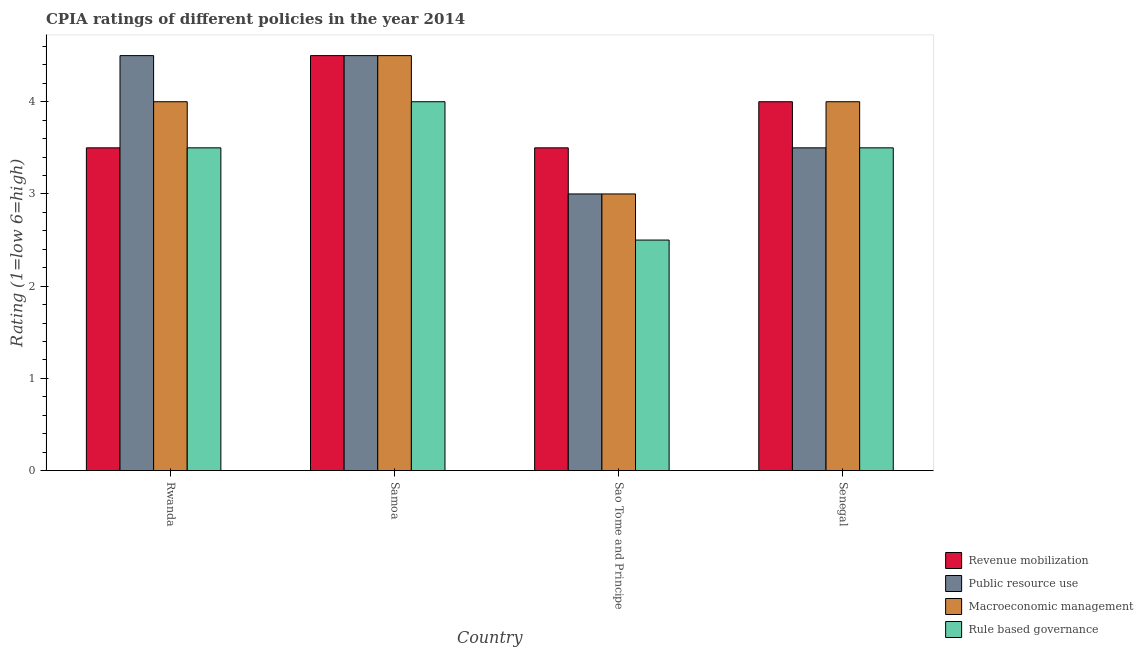How many different coloured bars are there?
Provide a succinct answer. 4. How many bars are there on the 4th tick from the right?
Offer a terse response. 4. What is the label of the 1st group of bars from the left?
Give a very brief answer. Rwanda. In how many cases, is the number of bars for a given country not equal to the number of legend labels?
Provide a succinct answer. 0. What is the cpia rating of public resource use in Rwanda?
Your response must be concise. 4.5. In which country was the cpia rating of public resource use maximum?
Your answer should be compact. Rwanda. In which country was the cpia rating of public resource use minimum?
Make the answer very short. Sao Tome and Principe. What is the difference between the cpia rating of public resource use in Rwanda and that in Sao Tome and Principe?
Provide a short and direct response. 1.5. What is the difference between the cpia rating of revenue mobilization in Samoa and the cpia rating of macroeconomic management in Sao Tome and Principe?
Your answer should be compact. 1.5. What is the average cpia rating of rule based governance per country?
Offer a very short reply. 3.38. What is the difference between the cpia rating of rule based governance and cpia rating of public resource use in Senegal?
Give a very brief answer. 0. In how many countries, is the cpia rating of public resource use greater than 0.6000000000000001 ?
Your answer should be very brief. 4. What is the ratio of the cpia rating of rule based governance in Samoa to that in Sao Tome and Principe?
Provide a succinct answer. 1.6. Is the difference between the cpia rating of public resource use in Samoa and Senegal greater than the difference between the cpia rating of revenue mobilization in Samoa and Senegal?
Offer a terse response. Yes. What is the difference between the highest and the second highest cpia rating of public resource use?
Your answer should be compact. 0. What does the 4th bar from the left in Sao Tome and Principe represents?
Ensure brevity in your answer.  Rule based governance. What does the 4th bar from the right in Samoa represents?
Provide a short and direct response. Revenue mobilization. Is it the case that in every country, the sum of the cpia rating of revenue mobilization and cpia rating of public resource use is greater than the cpia rating of macroeconomic management?
Keep it short and to the point. Yes. How many countries are there in the graph?
Keep it short and to the point. 4. What is the difference between two consecutive major ticks on the Y-axis?
Ensure brevity in your answer.  1. Does the graph contain grids?
Ensure brevity in your answer.  No. What is the title of the graph?
Keep it short and to the point. CPIA ratings of different policies in the year 2014. Does "Business regulatory environment" appear as one of the legend labels in the graph?
Provide a short and direct response. No. What is the Rating (1=low 6=high) in Public resource use in Rwanda?
Make the answer very short. 4.5. What is the Rating (1=low 6=high) in Rule based governance in Rwanda?
Offer a terse response. 3.5. What is the Rating (1=low 6=high) in Public resource use in Samoa?
Your answer should be compact. 4.5. What is the Rating (1=low 6=high) of Macroeconomic management in Samoa?
Your answer should be very brief. 4.5. What is the Rating (1=low 6=high) of Revenue mobilization in Sao Tome and Principe?
Offer a very short reply. 3.5. What is the Rating (1=low 6=high) of Rule based governance in Sao Tome and Principe?
Provide a succinct answer. 2.5. What is the Rating (1=low 6=high) in Revenue mobilization in Senegal?
Your response must be concise. 4. What is the Rating (1=low 6=high) in Public resource use in Senegal?
Your answer should be very brief. 3.5. What is the Rating (1=low 6=high) in Rule based governance in Senegal?
Your response must be concise. 3.5. Across all countries, what is the maximum Rating (1=low 6=high) of Revenue mobilization?
Offer a very short reply. 4.5. Across all countries, what is the maximum Rating (1=low 6=high) in Macroeconomic management?
Offer a very short reply. 4.5. Across all countries, what is the maximum Rating (1=low 6=high) in Rule based governance?
Provide a succinct answer. 4. Across all countries, what is the minimum Rating (1=low 6=high) in Public resource use?
Ensure brevity in your answer.  3. Across all countries, what is the minimum Rating (1=low 6=high) in Macroeconomic management?
Provide a short and direct response. 3. What is the total Rating (1=low 6=high) in Revenue mobilization in the graph?
Your answer should be compact. 15.5. What is the total Rating (1=low 6=high) in Public resource use in the graph?
Give a very brief answer. 15.5. What is the total Rating (1=low 6=high) in Rule based governance in the graph?
Your response must be concise. 13.5. What is the difference between the Rating (1=low 6=high) in Public resource use in Rwanda and that in Samoa?
Your response must be concise. 0. What is the difference between the Rating (1=low 6=high) of Macroeconomic management in Rwanda and that in Samoa?
Ensure brevity in your answer.  -0.5. What is the difference between the Rating (1=low 6=high) of Public resource use in Rwanda and that in Sao Tome and Principe?
Give a very brief answer. 1.5. What is the difference between the Rating (1=low 6=high) in Macroeconomic management in Rwanda and that in Sao Tome and Principe?
Your answer should be compact. 1. What is the difference between the Rating (1=low 6=high) of Revenue mobilization in Rwanda and that in Senegal?
Keep it short and to the point. -0.5. What is the difference between the Rating (1=low 6=high) in Public resource use in Samoa and that in Sao Tome and Principe?
Offer a very short reply. 1.5. What is the difference between the Rating (1=low 6=high) in Macroeconomic management in Samoa and that in Sao Tome and Principe?
Keep it short and to the point. 1.5. What is the difference between the Rating (1=low 6=high) of Revenue mobilization in Samoa and that in Senegal?
Your answer should be very brief. 0.5. What is the difference between the Rating (1=low 6=high) in Public resource use in Samoa and that in Senegal?
Make the answer very short. 1. What is the difference between the Rating (1=low 6=high) in Macroeconomic management in Samoa and that in Senegal?
Ensure brevity in your answer.  0.5. What is the difference between the Rating (1=low 6=high) of Rule based governance in Samoa and that in Senegal?
Keep it short and to the point. 0.5. What is the difference between the Rating (1=low 6=high) in Macroeconomic management in Sao Tome and Principe and that in Senegal?
Offer a terse response. -1. What is the difference between the Rating (1=low 6=high) of Rule based governance in Sao Tome and Principe and that in Senegal?
Ensure brevity in your answer.  -1. What is the difference between the Rating (1=low 6=high) of Revenue mobilization in Rwanda and the Rating (1=low 6=high) of Rule based governance in Samoa?
Your answer should be compact. -0.5. What is the difference between the Rating (1=low 6=high) of Public resource use in Rwanda and the Rating (1=low 6=high) of Rule based governance in Samoa?
Offer a terse response. 0.5. What is the difference between the Rating (1=low 6=high) of Revenue mobilization in Rwanda and the Rating (1=low 6=high) of Macroeconomic management in Sao Tome and Principe?
Provide a short and direct response. 0.5. What is the difference between the Rating (1=low 6=high) of Revenue mobilization in Rwanda and the Rating (1=low 6=high) of Rule based governance in Sao Tome and Principe?
Your answer should be compact. 1. What is the difference between the Rating (1=low 6=high) in Public resource use in Rwanda and the Rating (1=low 6=high) in Rule based governance in Sao Tome and Principe?
Provide a short and direct response. 2. What is the difference between the Rating (1=low 6=high) in Revenue mobilization in Rwanda and the Rating (1=low 6=high) in Public resource use in Senegal?
Keep it short and to the point. 0. What is the difference between the Rating (1=low 6=high) of Revenue mobilization in Rwanda and the Rating (1=low 6=high) of Macroeconomic management in Senegal?
Make the answer very short. -0.5. What is the difference between the Rating (1=low 6=high) of Revenue mobilization in Rwanda and the Rating (1=low 6=high) of Rule based governance in Senegal?
Offer a terse response. 0. What is the difference between the Rating (1=low 6=high) of Public resource use in Rwanda and the Rating (1=low 6=high) of Macroeconomic management in Senegal?
Your answer should be compact. 0.5. What is the difference between the Rating (1=low 6=high) in Macroeconomic management in Rwanda and the Rating (1=low 6=high) in Rule based governance in Senegal?
Your answer should be very brief. 0.5. What is the difference between the Rating (1=low 6=high) in Revenue mobilization in Samoa and the Rating (1=low 6=high) in Public resource use in Sao Tome and Principe?
Provide a succinct answer. 1.5. What is the difference between the Rating (1=low 6=high) of Public resource use in Samoa and the Rating (1=low 6=high) of Macroeconomic management in Sao Tome and Principe?
Offer a terse response. 1.5. What is the difference between the Rating (1=low 6=high) in Revenue mobilization in Samoa and the Rating (1=low 6=high) in Public resource use in Senegal?
Ensure brevity in your answer.  1. What is the difference between the Rating (1=low 6=high) of Public resource use in Samoa and the Rating (1=low 6=high) of Macroeconomic management in Senegal?
Your answer should be compact. 0.5. What is the difference between the Rating (1=low 6=high) in Public resource use in Samoa and the Rating (1=low 6=high) in Rule based governance in Senegal?
Ensure brevity in your answer.  1. What is the difference between the Rating (1=low 6=high) in Revenue mobilization in Sao Tome and Principe and the Rating (1=low 6=high) in Macroeconomic management in Senegal?
Your answer should be compact. -0.5. What is the difference between the Rating (1=low 6=high) in Revenue mobilization in Sao Tome and Principe and the Rating (1=low 6=high) in Rule based governance in Senegal?
Keep it short and to the point. 0. What is the difference between the Rating (1=low 6=high) of Public resource use in Sao Tome and Principe and the Rating (1=low 6=high) of Macroeconomic management in Senegal?
Make the answer very short. -1. What is the average Rating (1=low 6=high) in Revenue mobilization per country?
Give a very brief answer. 3.88. What is the average Rating (1=low 6=high) in Public resource use per country?
Offer a terse response. 3.88. What is the average Rating (1=low 6=high) in Macroeconomic management per country?
Offer a very short reply. 3.88. What is the average Rating (1=low 6=high) in Rule based governance per country?
Ensure brevity in your answer.  3.38. What is the difference between the Rating (1=low 6=high) in Revenue mobilization and Rating (1=low 6=high) in Macroeconomic management in Rwanda?
Provide a succinct answer. -0.5. What is the difference between the Rating (1=low 6=high) in Revenue mobilization and Rating (1=low 6=high) in Rule based governance in Rwanda?
Give a very brief answer. 0. What is the difference between the Rating (1=low 6=high) in Public resource use and Rating (1=low 6=high) in Macroeconomic management in Rwanda?
Keep it short and to the point. 0.5. What is the difference between the Rating (1=low 6=high) of Public resource use and Rating (1=low 6=high) of Rule based governance in Rwanda?
Your answer should be compact. 1. What is the difference between the Rating (1=low 6=high) of Macroeconomic management and Rating (1=low 6=high) of Rule based governance in Rwanda?
Ensure brevity in your answer.  0.5. What is the difference between the Rating (1=low 6=high) in Revenue mobilization and Rating (1=low 6=high) in Public resource use in Samoa?
Make the answer very short. 0. What is the difference between the Rating (1=low 6=high) in Revenue mobilization and Rating (1=low 6=high) in Public resource use in Sao Tome and Principe?
Ensure brevity in your answer.  0.5. What is the difference between the Rating (1=low 6=high) in Public resource use and Rating (1=low 6=high) in Macroeconomic management in Sao Tome and Principe?
Ensure brevity in your answer.  0. What is the difference between the Rating (1=low 6=high) of Public resource use and Rating (1=low 6=high) of Rule based governance in Sao Tome and Principe?
Give a very brief answer. 0.5. What is the difference between the Rating (1=low 6=high) of Revenue mobilization and Rating (1=low 6=high) of Public resource use in Senegal?
Provide a succinct answer. 0.5. What is the difference between the Rating (1=low 6=high) in Macroeconomic management and Rating (1=low 6=high) in Rule based governance in Senegal?
Provide a succinct answer. 0.5. What is the ratio of the Rating (1=low 6=high) in Revenue mobilization in Rwanda to that in Samoa?
Your answer should be very brief. 0.78. What is the ratio of the Rating (1=low 6=high) in Rule based governance in Rwanda to that in Samoa?
Offer a terse response. 0.88. What is the ratio of the Rating (1=low 6=high) of Macroeconomic management in Rwanda to that in Sao Tome and Principe?
Make the answer very short. 1.33. What is the ratio of the Rating (1=low 6=high) in Rule based governance in Rwanda to that in Sao Tome and Principe?
Provide a succinct answer. 1.4. What is the ratio of the Rating (1=low 6=high) in Revenue mobilization in Rwanda to that in Senegal?
Ensure brevity in your answer.  0.88. What is the ratio of the Rating (1=low 6=high) in Rule based governance in Samoa to that in Sao Tome and Principe?
Your answer should be very brief. 1.6. What is the ratio of the Rating (1=low 6=high) in Macroeconomic management in Samoa to that in Senegal?
Give a very brief answer. 1.12. What is the ratio of the Rating (1=low 6=high) of Rule based governance in Samoa to that in Senegal?
Provide a short and direct response. 1.14. What is the ratio of the Rating (1=low 6=high) in Rule based governance in Sao Tome and Principe to that in Senegal?
Ensure brevity in your answer.  0.71. What is the difference between the highest and the second highest Rating (1=low 6=high) in Revenue mobilization?
Keep it short and to the point. 0.5. What is the difference between the highest and the second highest Rating (1=low 6=high) of Macroeconomic management?
Your answer should be very brief. 0.5. What is the difference between the highest and the second highest Rating (1=low 6=high) of Rule based governance?
Provide a succinct answer. 0.5. What is the difference between the highest and the lowest Rating (1=low 6=high) in Revenue mobilization?
Offer a very short reply. 1. What is the difference between the highest and the lowest Rating (1=low 6=high) in Public resource use?
Make the answer very short. 1.5. What is the difference between the highest and the lowest Rating (1=low 6=high) in Rule based governance?
Your answer should be very brief. 1.5. 